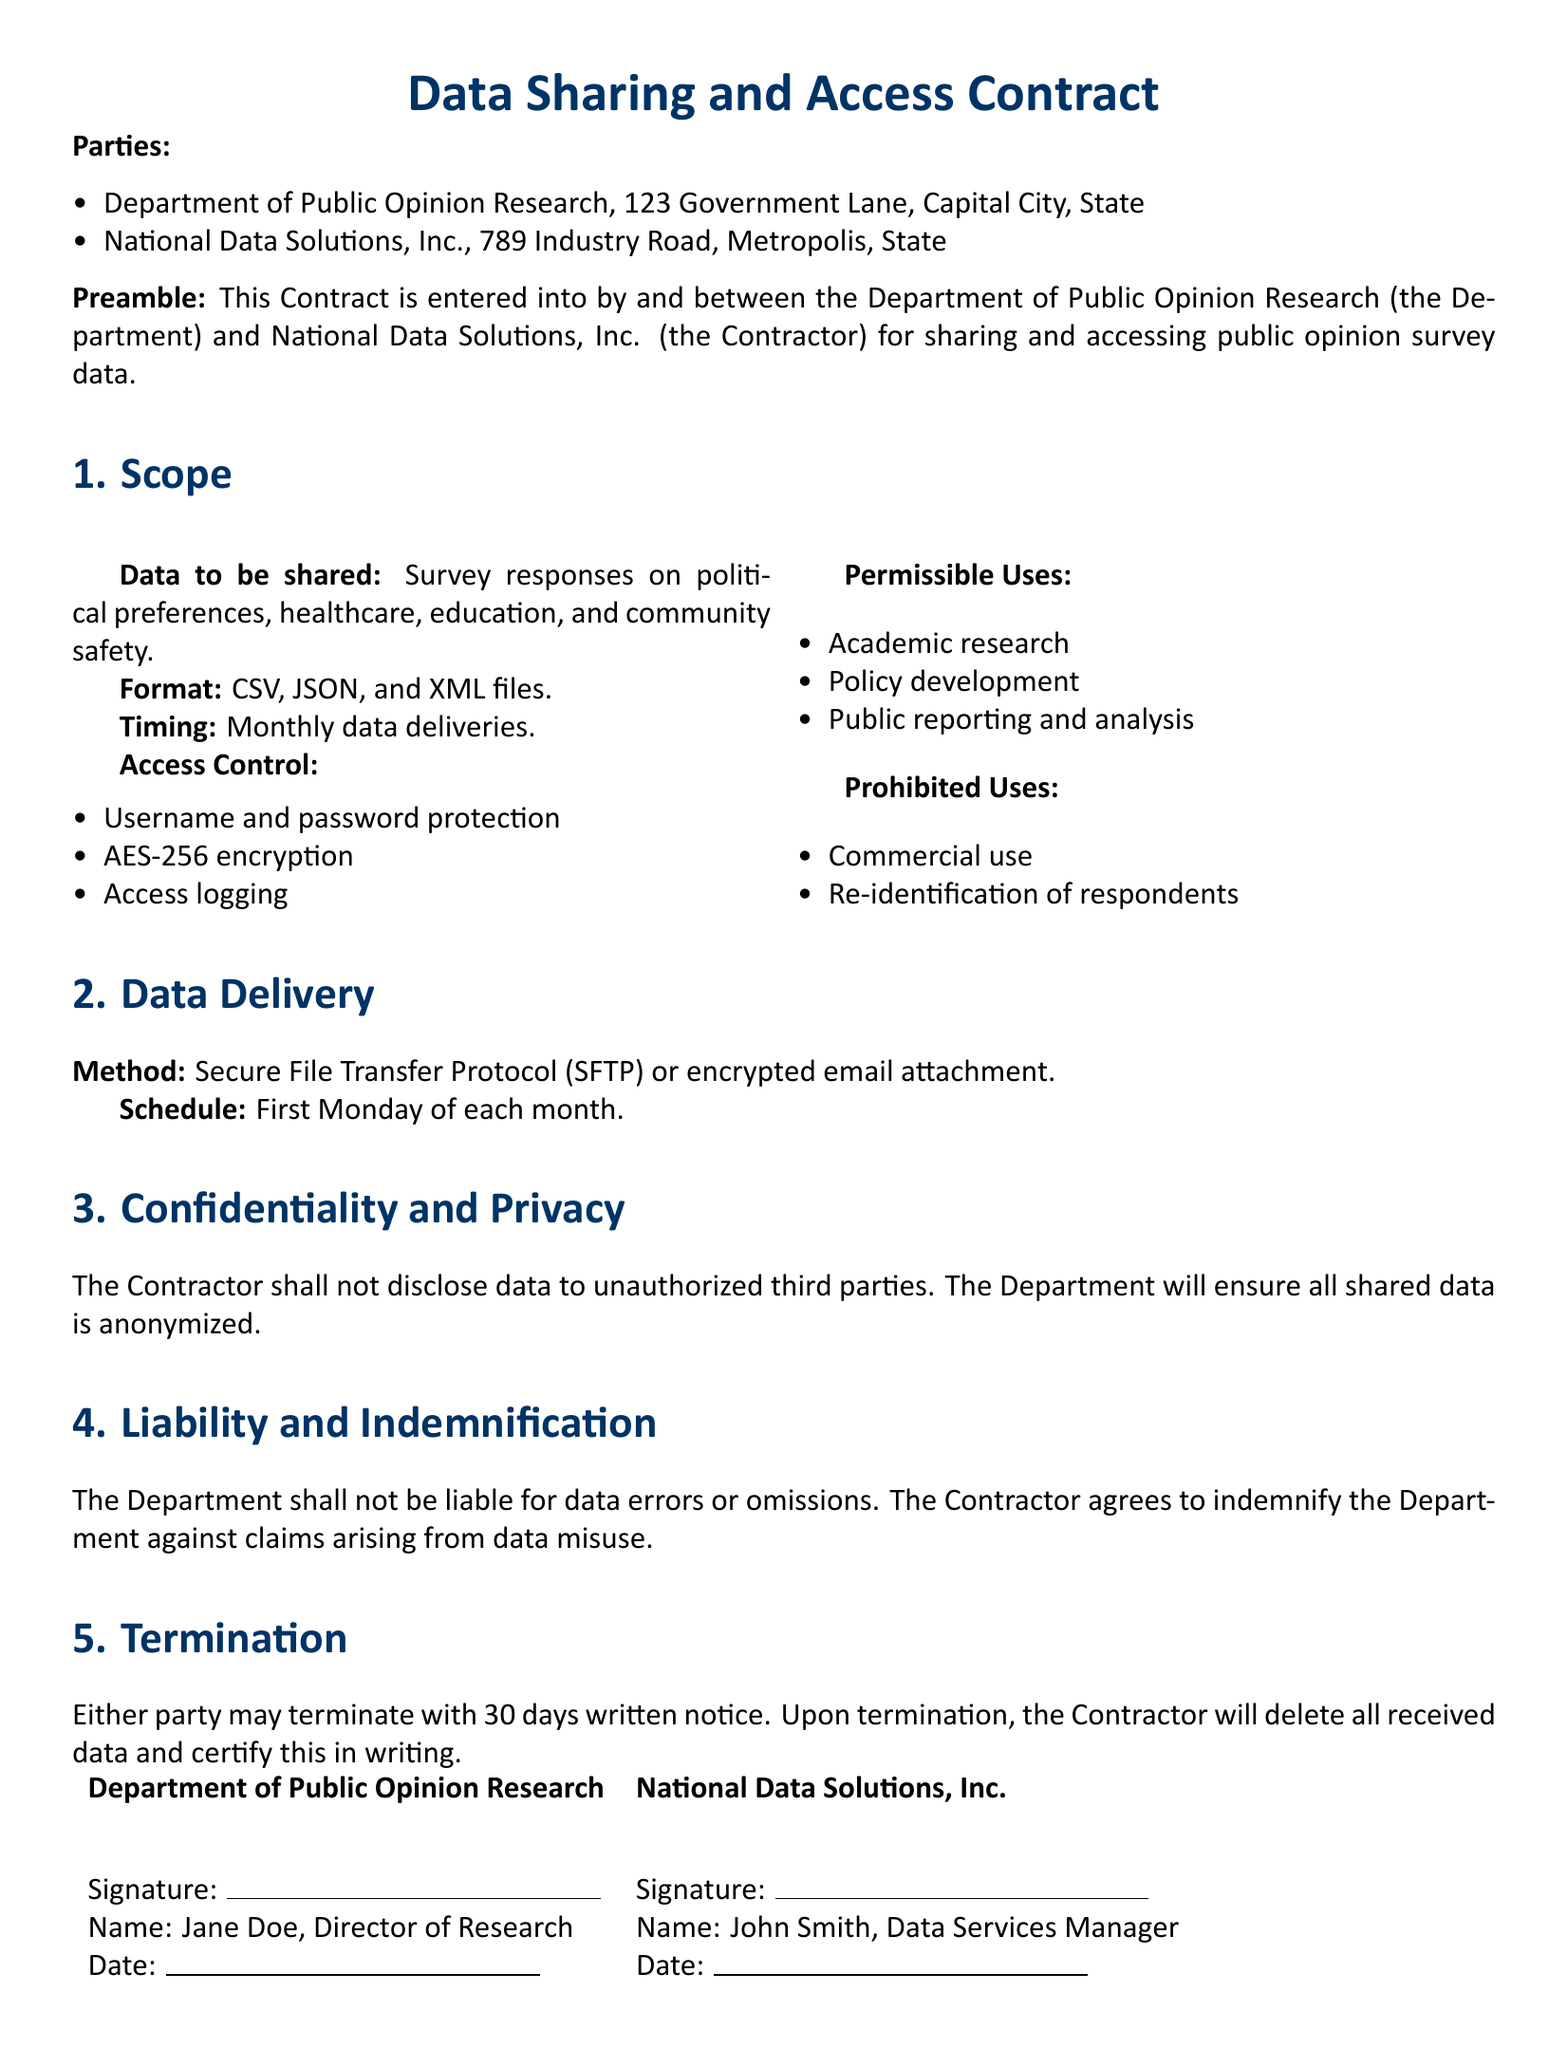What is the name of the department involved? The document states the name of the department as "Department of Public Opinion Research."
Answer: Department of Public Opinion Research What types of data will be shared? The document mentions that data to be shared includes survey responses on political preferences, healthcare, education, and community safety.
Answer: Political preferences, healthcare, education, and community safety What is the format of the shared data? According to the document, the format of the shared data is CSV, JSON, and XML files.
Answer: CSV, JSON, and XML files How often will data be delivered? The document indicates that data deliveries will occur monthly, specifically on the first Monday of each month.
Answer: Monthly What encryption method is specified for access control? The document specifies that AES-256 encryption will be used for access control.
Answer: AES-256 encryption What are the permissible uses of the data? The document lists permissible uses that include academic research, policy development, and public reporting and analysis.
Answer: Academic research, policy development, and public reporting and analysis Who must sign this contract? The document states that the signatures of the Director of Research and the Data Services Manager are required to finalize the contract.
Answer: Director of Research and Data Services Manager What is the termination notice period? The document specifies that either party may terminate the contract with a written notice of 30 days.
Answer: 30 days 